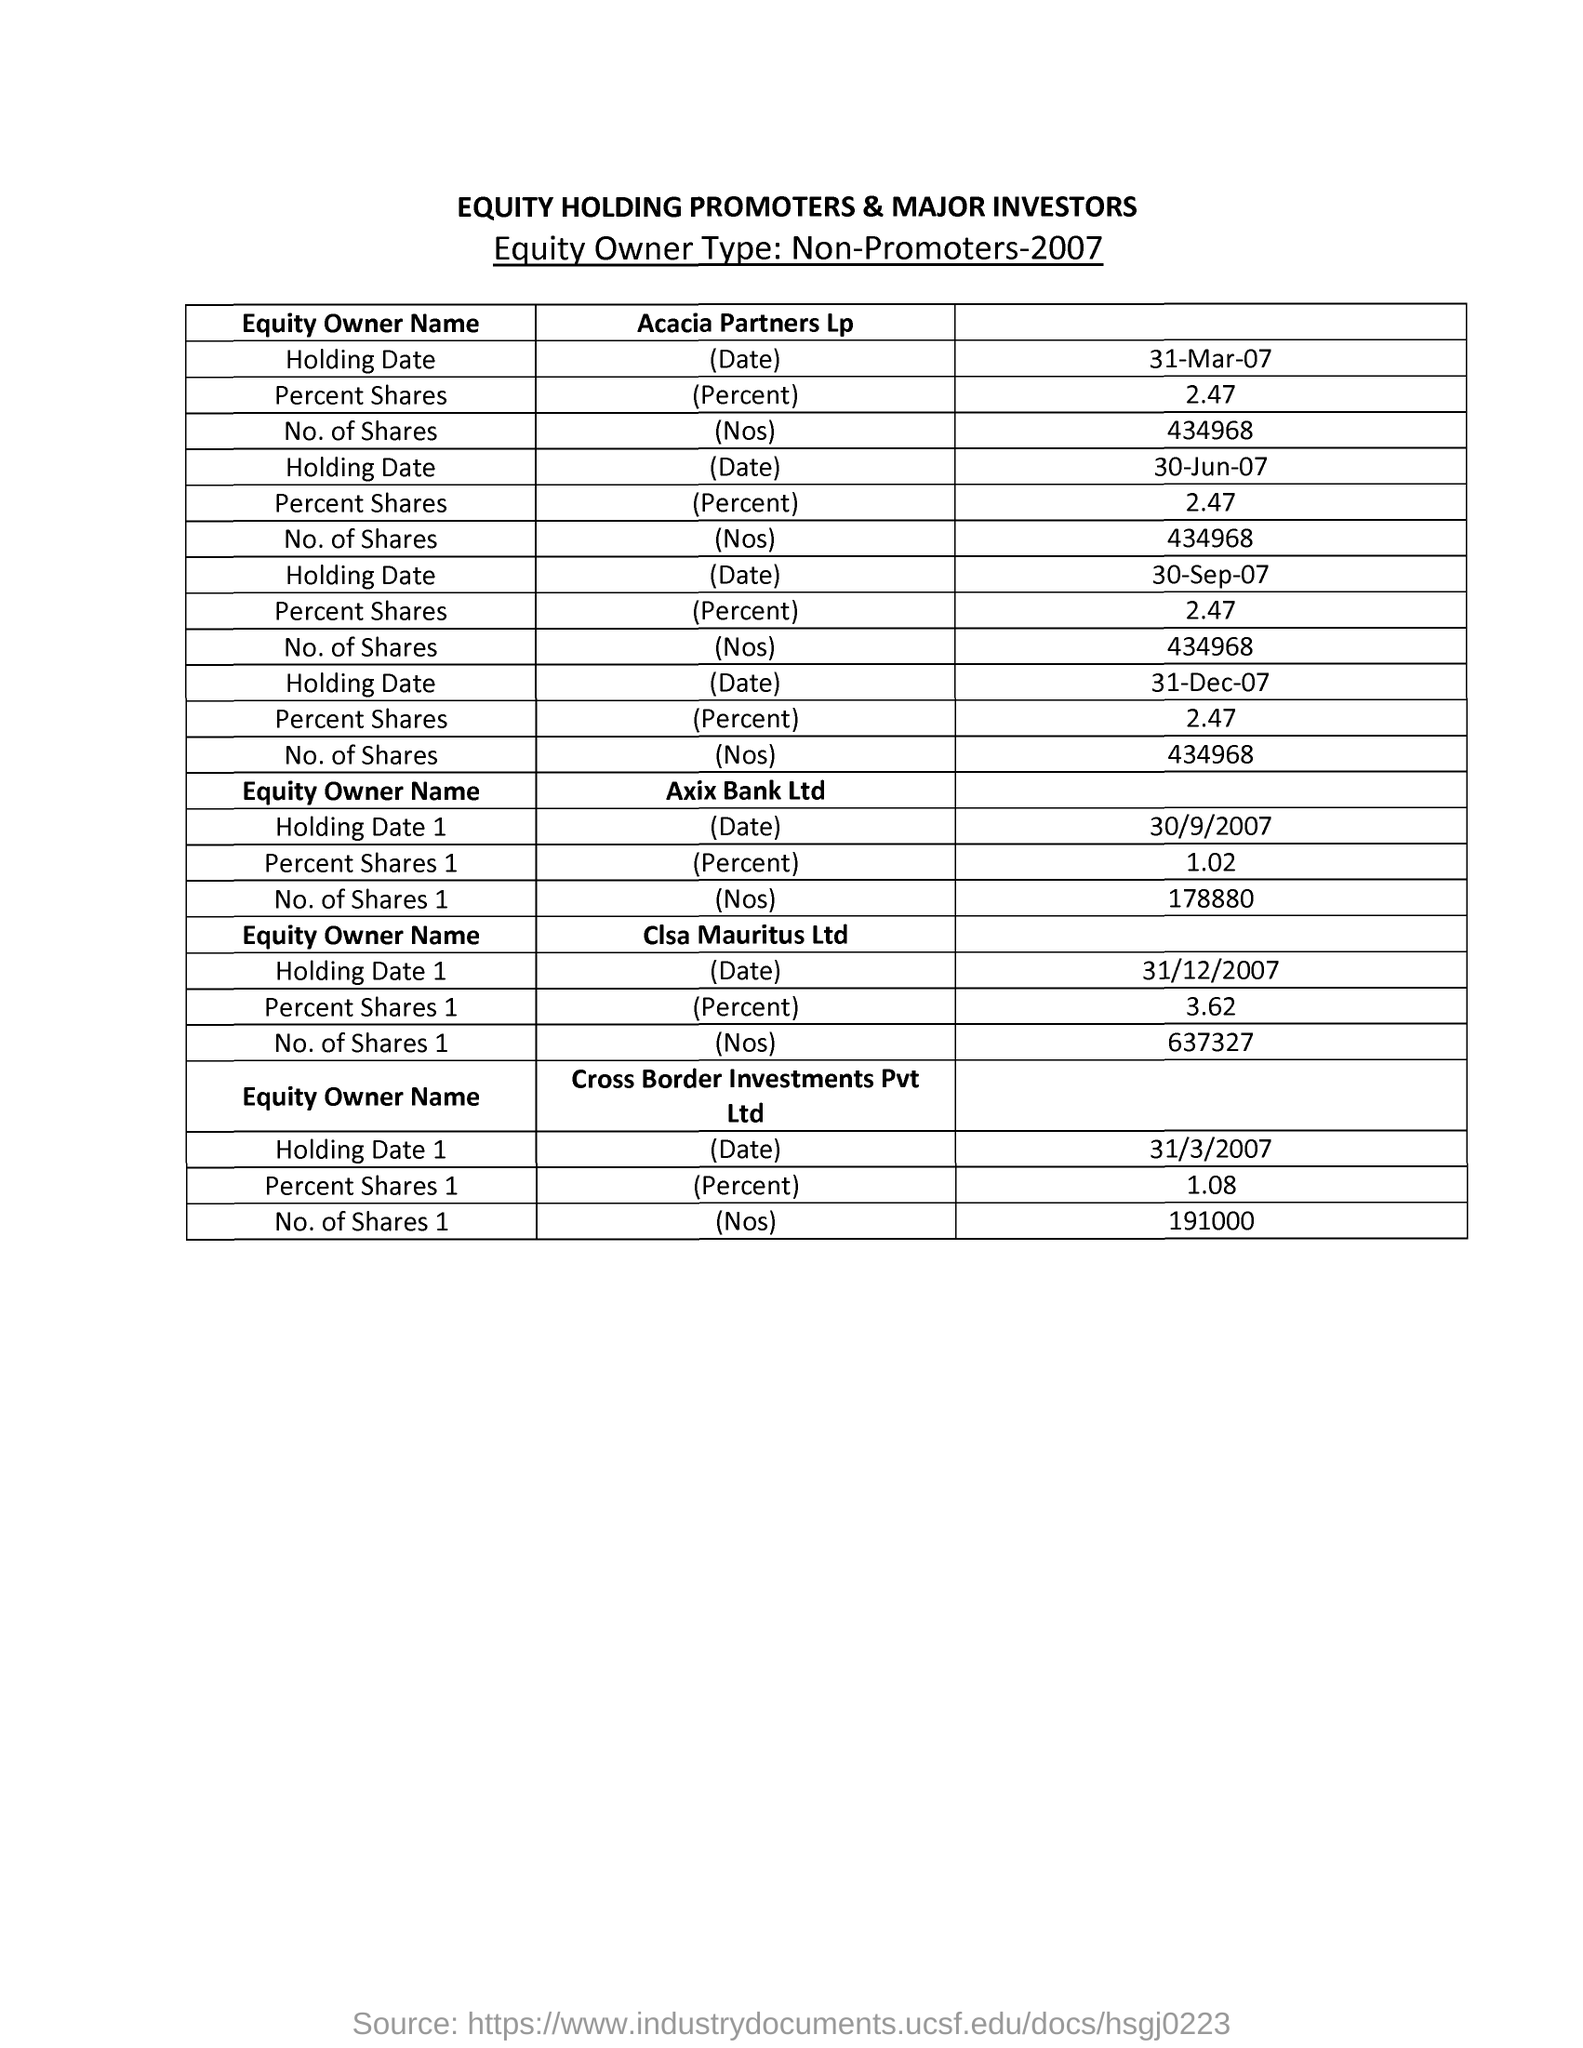What is the heading of the document?
Provide a succinct answer. EQUITY HOLDING PROMOTERS & MAJOR INVESTORS. 